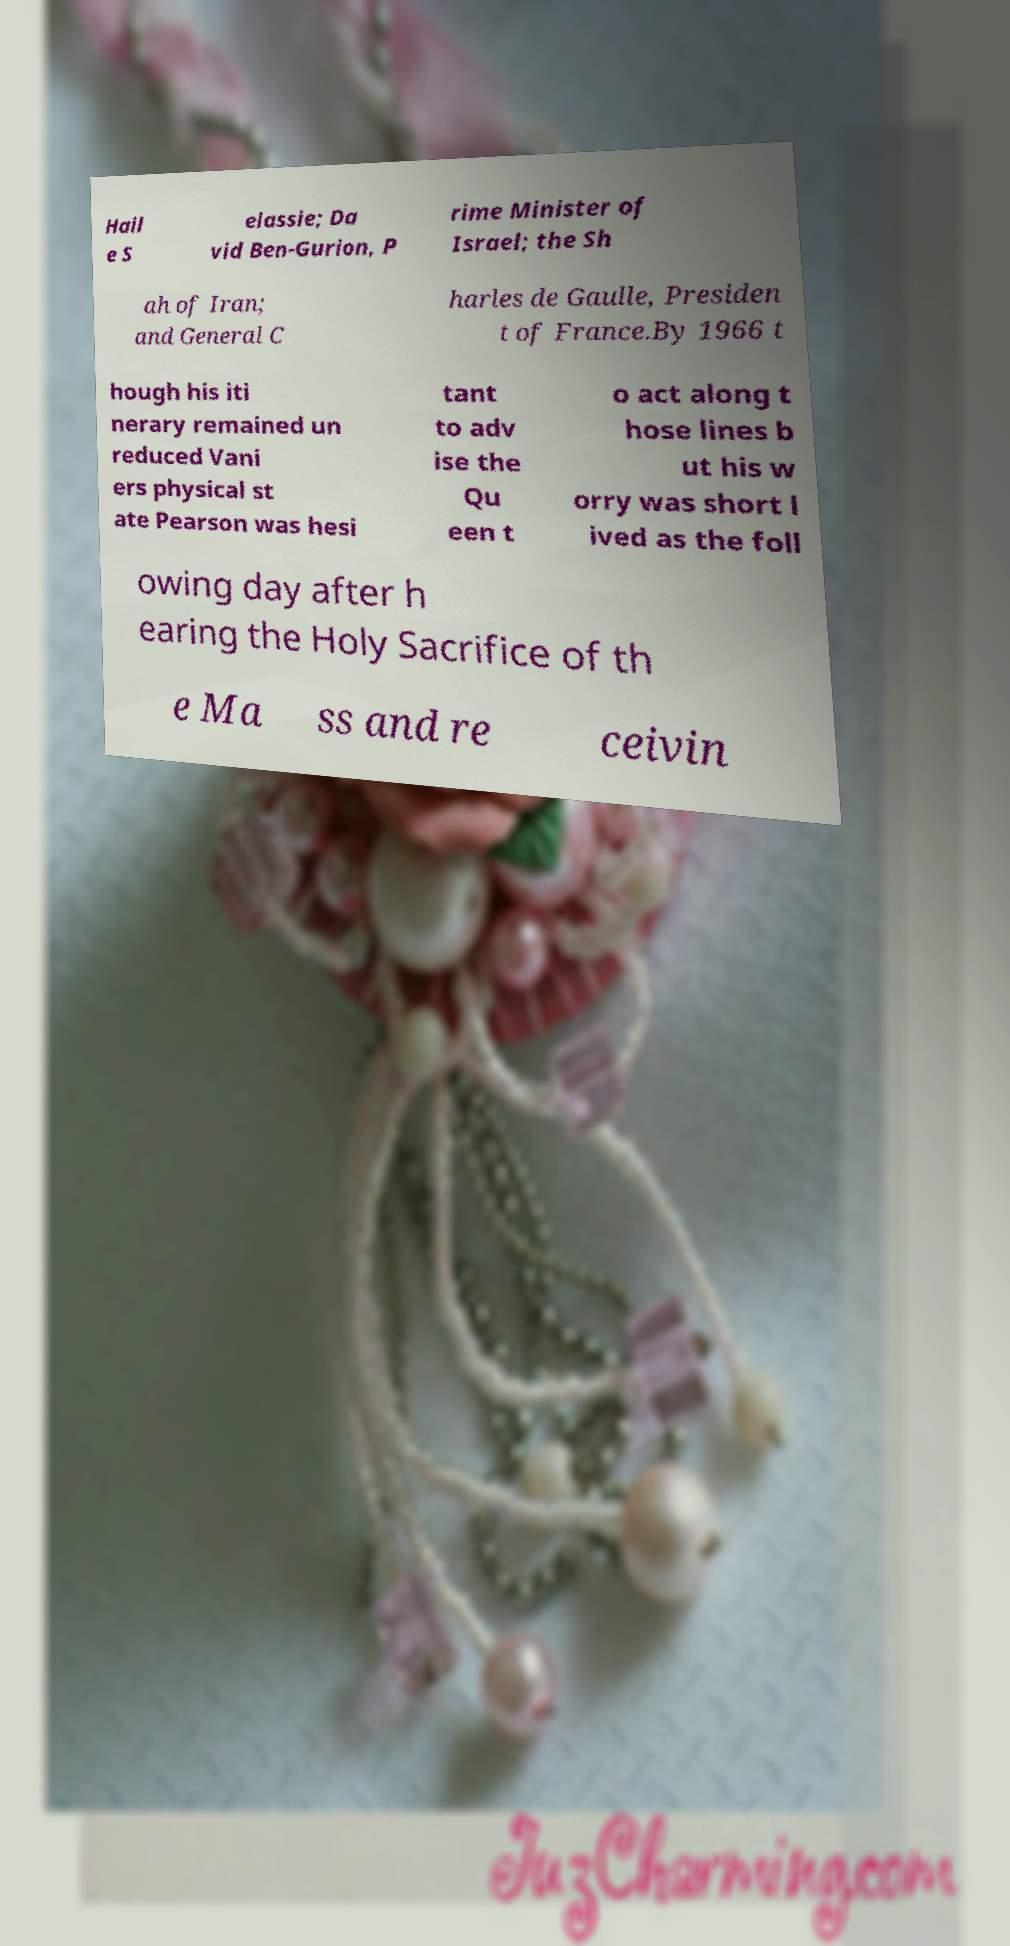Can you accurately transcribe the text from the provided image for me? Hail e S elassie; Da vid Ben-Gurion, P rime Minister of Israel; the Sh ah of Iran; and General C harles de Gaulle, Presiden t of France.By 1966 t hough his iti nerary remained un reduced Vani ers physical st ate Pearson was hesi tant to adv ise the Qu een t o act along t hose lines b ut his w orry was short l ived as the foll owing day after h earing the Holy Sacrifice of th e Ma ss and re ceivin 